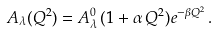Convert formula to latex. <formula><loc_0><loc_0><loc_500><loc_500>A _ { \lambda } ( Q ^ { 2 } ) = A _ { \lambda } ^ { 0 } \, ( 1 + \alpha \, Q ^ { 2 } ) e ^ { - \beta Q ^ { 2 } } \, .</formula> 